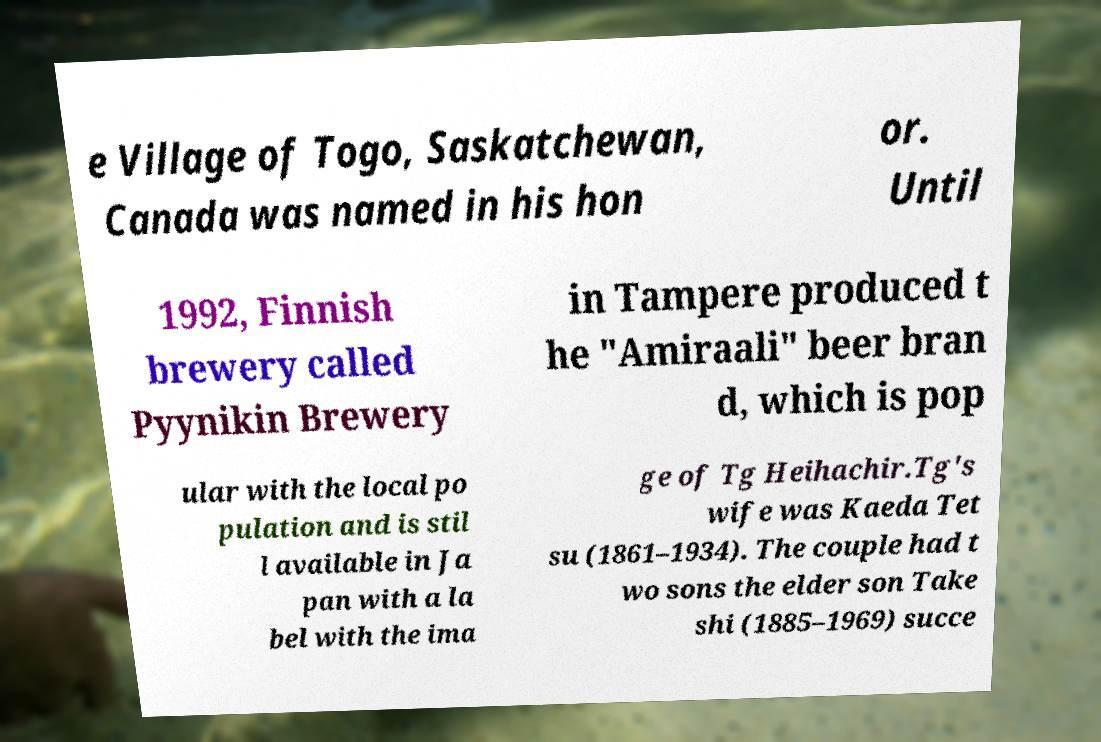Could you extract and type out the text from this image? e Village of Togo, Saskatchewan, Canada was named in his hon or. Until 1992, Finnish brewery called Pyynikin Brewery in Tampere produced t he "Amiraali" beer bran d, which is pop ular with the local po pulation and is stil l available in Ja pan with a la bel with the ima ge of Tg Heihachir.Tg's wife was Kaeda Tet su (1861–1934). The couple had t wo sons the elder son Take shi (1885–1969) succe 